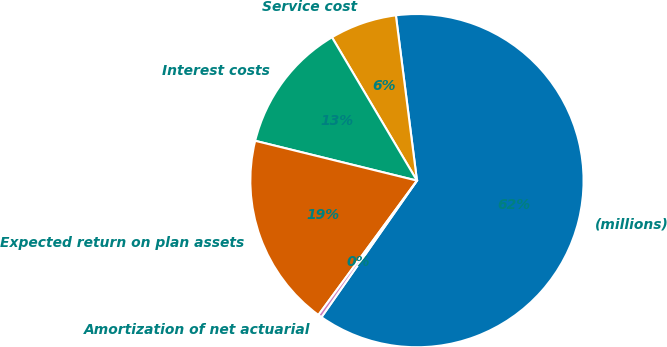<chart> <loc_0><loc_0><loc_500><loc_500><pie_chart><fcel>(millions)<fcel>Service cost<fcel>Interest costs<fcel>Expected return on plan assets<fcel>Amortization of net actuarial<nl><fcel>61.73%<fcel>6.5%<fcel>12.64%<fcel>18.77%<fcel>0.36%<nl></chart> 